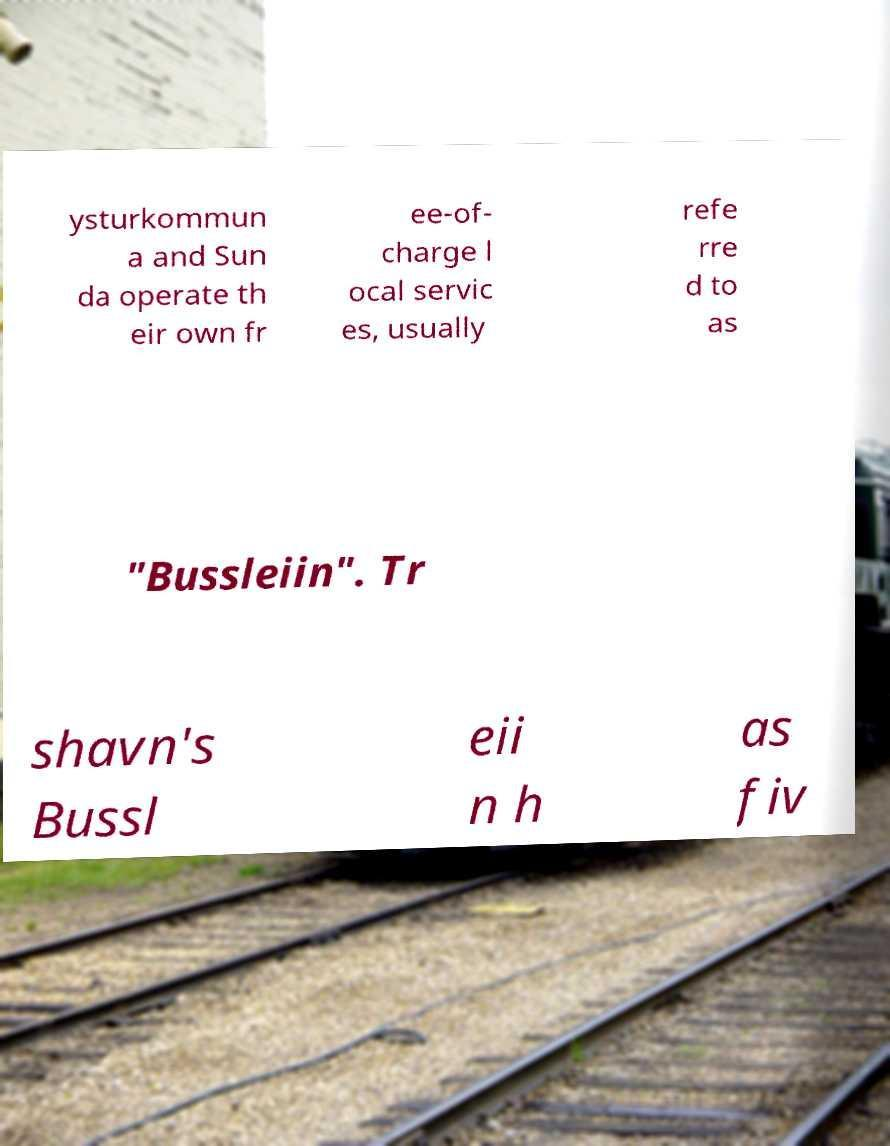I need the written content from this picture converted into text. Can you do that? ysturkommun a and Sun da operate th eir own fr ee-of- charge l ocal servic es, usually refe rre d to as "Bussleiin". Tr shavn's Bussl eii n h as fiv 